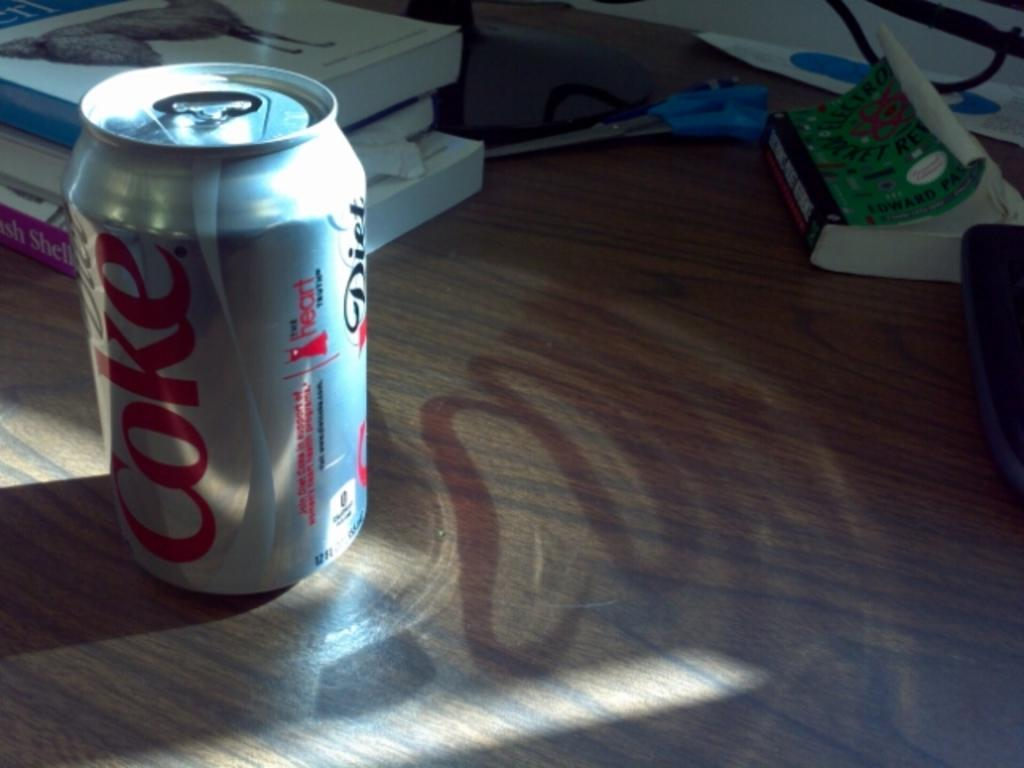<image>
Give a short and clear explanation of the subsequent image. An open can of Diet Coke is sitting on a wooden surface with books and scissors. 